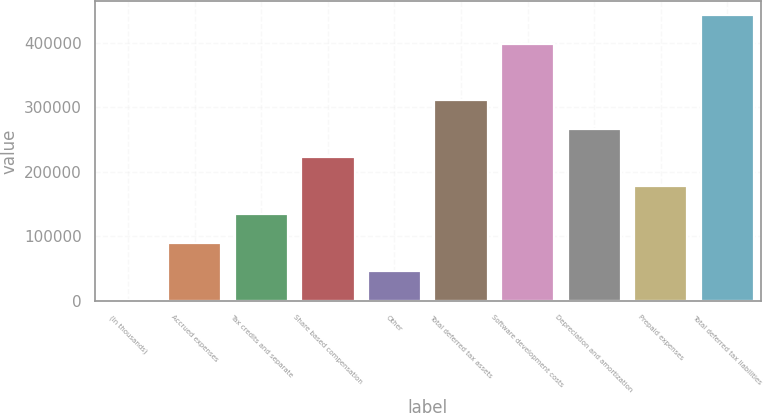Convert chart. <chart><loc_0><loc_0><loc_500><loc_500><bar_chart><fcel>(In thousands)<fcel>Accrued expenses<fcel>Tax credits and separate<fcel>Share based compensation<fcel>Other<fcel>Total deferred tax assets<fcel>Software development costs<fcel>Depreciation and amortization<fcel>Prepaid expenses<fcel>Total deferred tax liabilities<nl><fcel>2016<fcel>90136.2<fcel>134196<fcel>222316<fcel>46076.1<fcel>310437<fcel>398557<fcel>266377<fcel>178256<fcel>442617<nl></chart> 